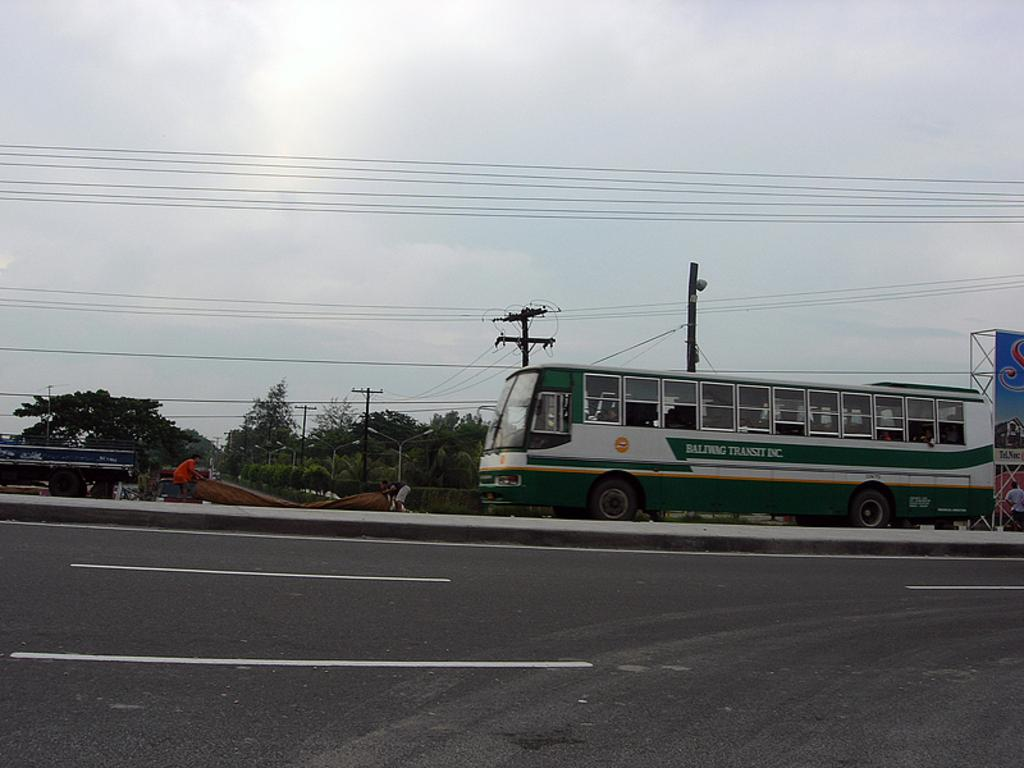What is the main feature of the image? There is a road in the image. What type of vehicle can be seen on the road? There is a bus on the road. Are there any other vehicles on the road besides the bus? Yes, there is at least one other vehicle on the road. What can be seen in the background behind the vehicles? There are trees visible behind the vehicles. What type of infrastructure is visible in the image? There are current poles visible in the image. What time of day is the story taking place in the image? The image does not depict a story, and there is no indication of the time of day. What type of earth is visible in the image? The image does not show any specific type of earth; it primarily features a road, vehicles, trees, and current poles. 